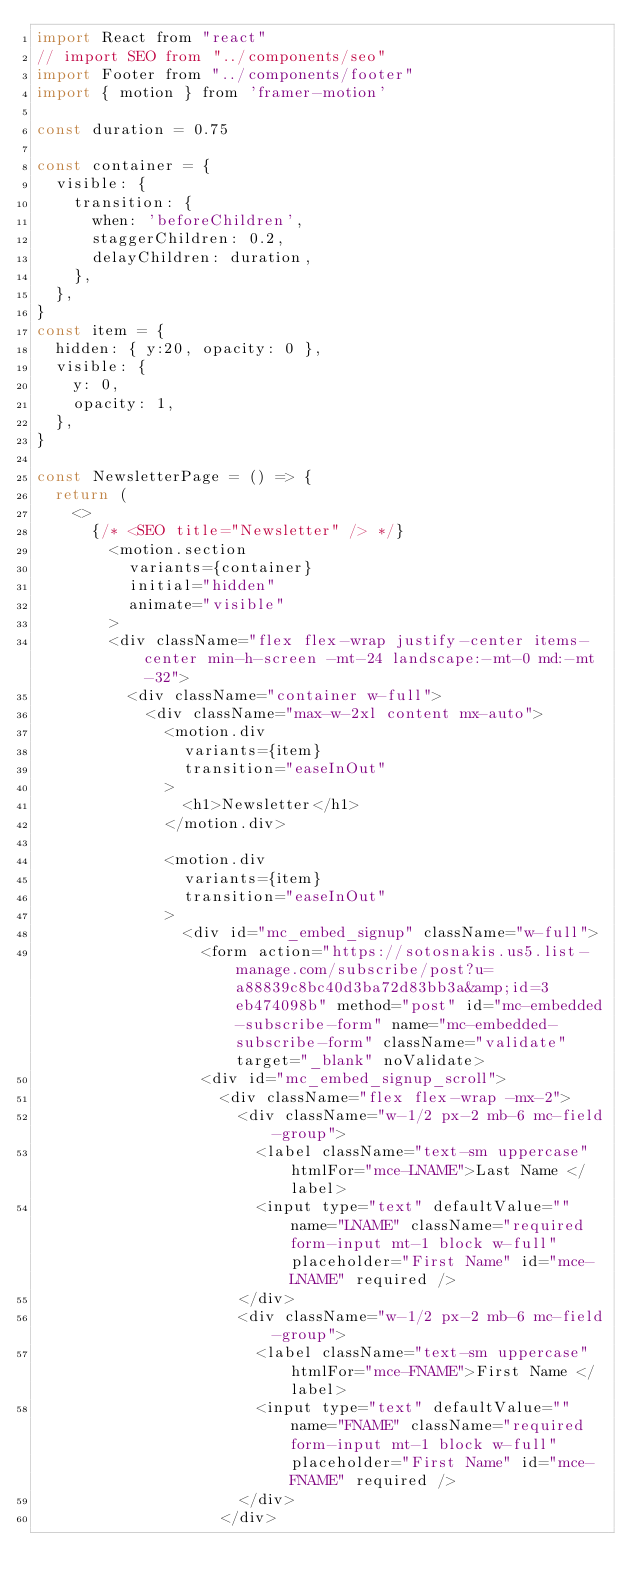<code> <loc_0><loc_0><loc_500><loc_500><_JavaScript_>import React from "react"
// import SEO from "../components/seo"
import Footer from "../components/footer"
import { motion } from 'framer-motion'

const duration = 0.75

const container = {
  visible: {
    transition: {
      when: 'beforeChildren',
      staggerChildren: 0.2,
      delayChildren: duration,
    },
  },
}
const item = {
  hidden: { y:20, opacity: 0 },
  visible: {
    y: 0,
    opacity: 1,
  },
}

const NewsletterPage = () => {
  return (
    <>
      {/* <SEO title="Newsletter" /> */}
        <motion.section
          variants={container}
          initial="hidden" 
          animate="visible"
        >
        <div className="flex flex-wrap justify-center items-center min-h-screen -mt-24 landscape:-mt-0 md:-mt-32">
          <div className="container w-full">
            <div className="max-w-2xl content mx-auto">
              <motion.div 
                variants={item}
                transition="easeInOut"
              >
                <h1>Newsletter</h1>
              </motion.div>

              <motion.div 
                variants={item}
                transition="easeInOut"
              >
                <div id="mc_embed_signup" className="w-full">
                  <form action="https://sotosnakis.us5.list-manage.com/subscribe/post?u=a88839c8bc40d3ba72d83bb3a&amp;id=3eb474098b" method="post" id="mc-embedded-subscribe-form" name="mc-embedded-subscribe-form" className="validate" target="_blank" noValidate>
                  <div id="mc_embed_signup_scroll">  
                    <div className="flex flex-wrap -mx-2">
                      <div className="w-1/2 px-2 mb-6 mc-field-group">
                        <label className="text-sm uppercase" htmlFor="mce-LNAME">Last Name </label>
                        <input type="text" defaultValue="" name="LNAME" className="required form-input mt-1 block w-full" placeholder="First Name" id="mce-LNAME" required />
                      </div>
                      <div className="w-1/2 px-2 mb-6 mc-field-group">
                        <label className="text-sm uppercase" htmlFor="mce-FNAME">First Name </label>
                        <input type="text" defaultValue="" name="FNAME" className="required form-input mt-1 block w-full" placeholder="First Name" id="mce-FNAME" required />
                      </div>
                    </div></code> 